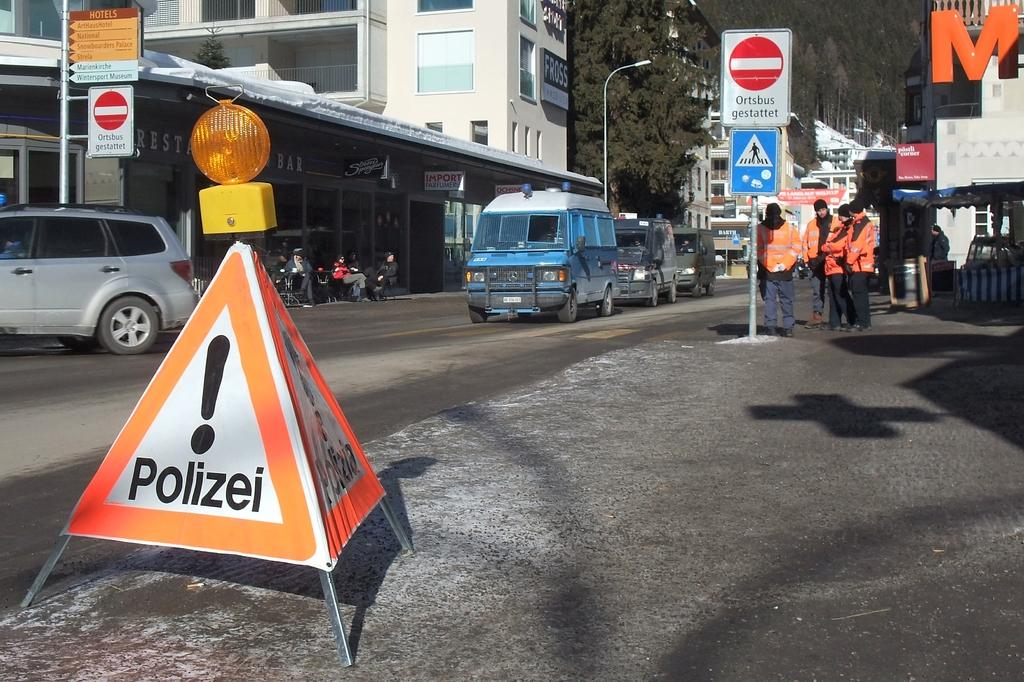<image>
Present a compact description of the photo's key features. A road with cars and a triangular sign that has an explanation point and under it the word Polizei is in black letters. 